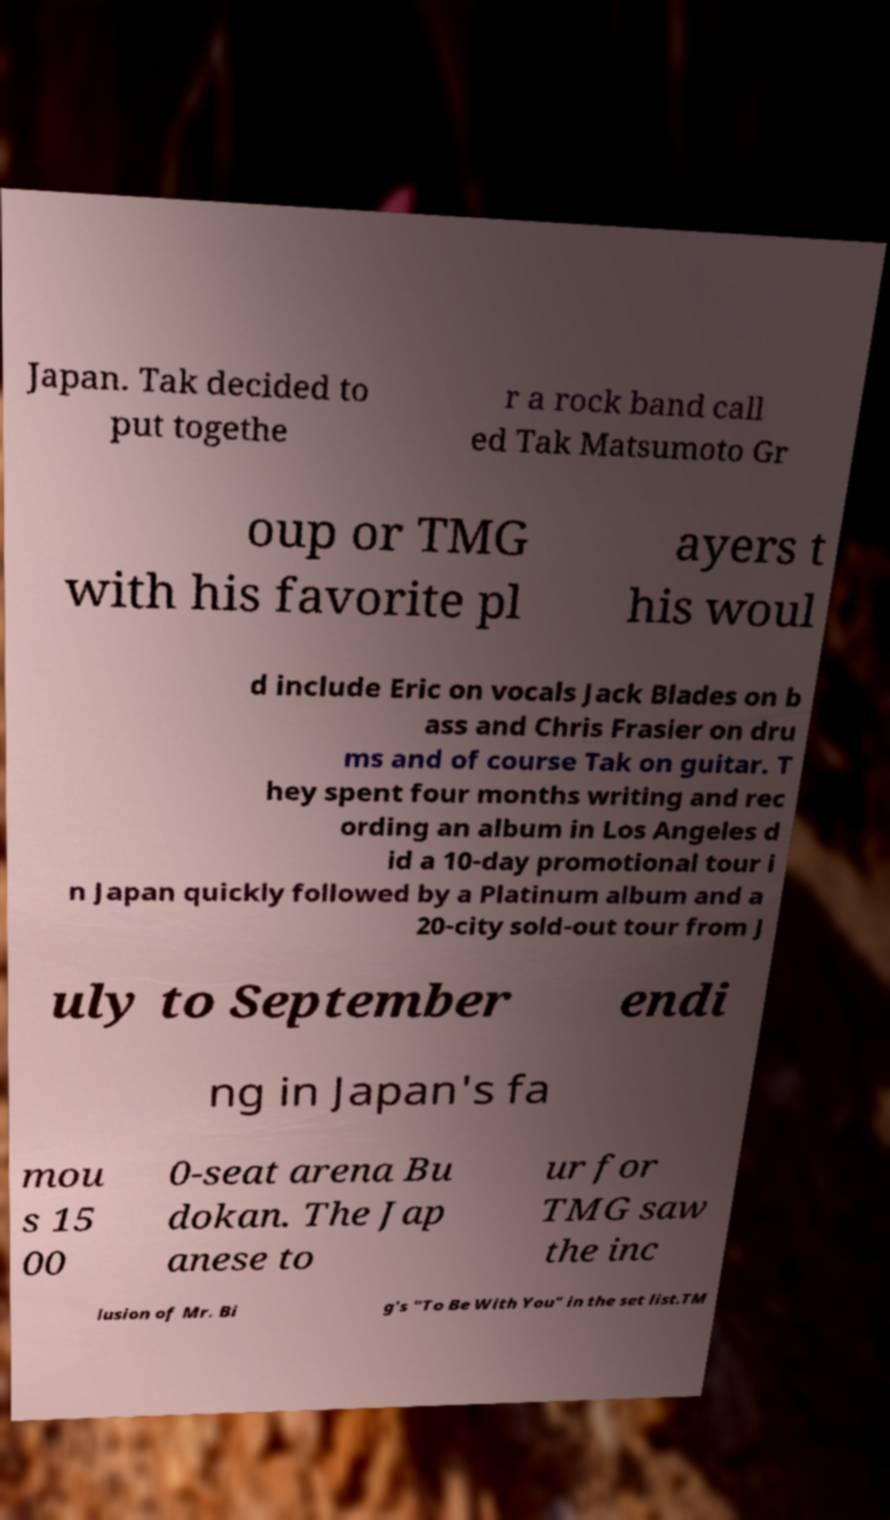Can you accurately transcribe the text from the provided image for me? Japan. Tak decided to put togethe r a rock band call ed Tak Matsumoto Gr oup or TMG with his favorite pl ayers t his woul d include Eric on vocals Jack Blades on b ass and Chris Frasier on dru ms and of course Tak on guitar. T hey spent four months writing and rec ording an album in Los Angeles d id a 10-day promotional tour i n Japan quickly followed by a Platinum album and a 20-city sold-out tour from J uly to September endi ng in Japan's fa mou s 15 00 0-seat arena Bu dokan. The Jap anese to ur for TMG saw the inc lusion of Mr. Bi g's "To Be With You" in the set list.TM 